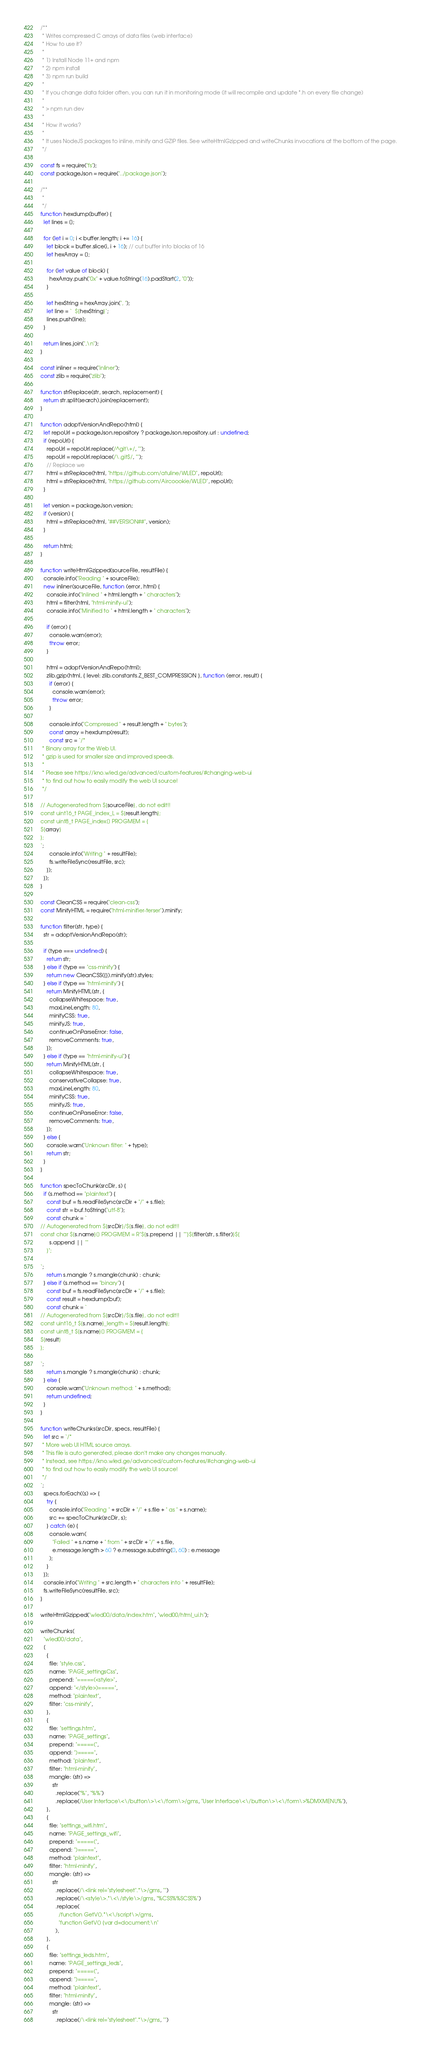<code> <loc_0><loc_0><loc_500><loc_500><_JavaScript_>/**
 * Writes compressed C arrays of data files (web interface)
 * How to use it?
 *
 * 1) Install Node 11+ and npm
 * 2) npm install
 * 3) npm run build
 *
 * If you change data folder often, you can run it in monitoring mode (it will recompile and update *.h on every file change)
 *
 * > npm run dev
 *
 * How it works?
 *
 * It uses NodeJS packages to inline, minify and GZIP files. See writeHtmlGzipped and writeChunks invocations at the bottom of the page.
 */

const fs = require("fs");
const packageJson = require("../package.json");

/**
 *
 */
function hexdump(buffer) {
  let lines = [];

  for (let i = 0; i < buffer.length; i += 16) {
    let block = buffer.slice(i, i + 16); // cut buffer into blocks of 16
    let hexArray = [];

    for (let value of block) {
      hexArray.push("0x" + value.toString(16).padStart(2, "0"));
    }

    let hexString = hexArray.join(", ");
    let line = `  ${hexString}`;
    lines.push(line);
  }

  return lines.join(",\n");
}

const inliner = require("inliner");
const zlib = require("zlib");

function strReplace(str, search, replacement) {
  return str.split(search).join(replacement);
}

function adoptVersionAndRepo(html) {
  let repoUrl = packageJson.repository ? packageJson.repository.url : undefined;
  if (repoUrl) {
    repoUrl = repoUrl.replace(/^git\+/, "");
    repoUrl = repoUrl.replace(/\.git$/, "");
    // Replace we
    html = strReplace(html, "https://github.com/atuline/WLED", repoUrl);
    html = strReplace(html, "https://github.com/Aircoookie/WLED", repoUrl);
  }

  let version = packageJson.version;
  if (version) {
    html = strReplace(html, "##VERSION##", version);
  }

  return html;
}

function writeHtmlGzipped(sourceFile, resultFile) {
  console.info("Reading " + sourceFile);
  new inliner(sourceFile, function (error, html) {
    console.info("Inlined " + html.length + " characters");
    html = filter(html, "html-minify-ui");
    console.info("Minified to " + html.length + " characters");

    if (error) {
      console.warn(error);
      throw error;
    }

    html = adoptVersionAndRepo(html);
    zlib.gzip(html, { level: zlib.constants.Z_BEST_COMPRESSION }, function (error, result) {
      if (error) {
        console.warn(error);
        throw error;
      }

      console.info("Compressed " + result.length + " bytes");
      const array = hexdump(result);
      const src = `/*
 * Binary array for the Web UI.
 * gzip is used for smaller size and improved speeds.
 * 
 * Please see https://kno.wled.ge/advanced/custom-features/#changing-web-ui
 * to find out how to easily modify the web UI source!
 */
 
// Autogenerated from ${sourceFile}, do not edit!!
const uint16_t PAGE_index_L = ${result.length};
const uint8_t PAGE_index[] PROGMEM = {
${array}
};
`;
      console.info("Writing " + resultFile);
      fs.writeFileSync(resultFile, src);
    });
  });
}

const CleanCSS = require("clean-css");
const MinifyHTML = require("html-minifier-terser").minify;

function filter(str, type) {
  str = adoptVersionAndRepo(str);

  if (type === undefined) {
    return str;
  } else if (type == "css-minify") {
    return new CleanCSS({}).minify(str).styles;
  } else if (type == "html-minify") {
    return MinifyHTML(str, {
      collapseWhitespace: true,
      maxLineLength: 80,
      minifyCSS: true,
      minifyJS: true, 
      continueOnParseError: false,
      removeComments: true,
    });
  } else if (type == "html-minify-ui") {
    return MinifyHTML(str, {
      collapseWhitespace: true,
      conservativeCollapse: true,
      maxLineLength: 80,
      minifyCSS: true,
      minifyJS: true, 
      continueOnParseError: false,
      removeComments: true,
    });
  } else {
    console.warn("Unknown filter: " + type);
    return str;
  }
}

function specToChunk(srcDir, s) {
  if (s.method == "plaintext") {
    const buf = fs.readFileSync(srcDir + "/" + s.file);
    const str = buf.toString("utf-8");
    const chunk = `
// Autogenerated from ${srcDir}/${s.file}, do not edit!!
const char ${s.name}[] PROGMEM = R"${s.prepend || ""}${filter(str, s.filter)}${
      s.append || ""
    }";

`;
    return s.mangle ? s.mangle(chunk) : chunk;
  } else if (s.method == "binary") {
    const buf = fs.readFileSync(srcDir + "/" + s.file);
    const result = hexdump(buf);
    const chunk = `
// Autogenerated from ${srcDir}/${s.file}, do not edit!!
const uint16_t ${s.name}_length = ${result.length};
const uint8_t ${s.name}[] PROGMEM = {
${result}
};

`;
    return s.mangle ? s.mangle(chunk) : chunk;
  } else {
    console.warn("Unknown method: " + s.method);
    return undefined;
  }
}

function writeChunks(srcDir, specs, resultFile) {
  let src = `/*
 * More web UI HTML source arrays.
 * This file is auto generated, please don't make any changes manually.
 * Instead, see https://kno.wled.ge/advanced/custom-features/#changing-web-ui
 * to find out how to easily modify the web UI source!
 */ 
`;
  specs.forEach((s) => {
    try {
      console.info("Reading " + srcDir + "/" + s.file + " as " + s.name);
      src += specToChunk(srcDir, s);
    } catch (e) {
      console.warn(
        "Failed " + s.name + " from " + srcDir + "/" + s.file,
        e.message.length > 60 ? e.message.substring(0, 60) : e.message
      );
    }
  });
  console.info("Writing " + src.length + " characters into " + resultFile);
  fs.writeFileSync(resultFile, src);
}

writeHtmlGzipped("wled00/data/index.htm", "wled00/html_ui.h");

writeChunks(
  "wled00/data",
  [
    {
      file: "style.css",
      name: "PAGE_settingsCss",
      prepend: "=====(<style>",
      append: "</style>)=====",
      method: "plaintext",
      filter: "css-minify",
    },
    {
      file: "settings.htm",
      name: "PAGE_settings",
      prepend: "=====(",
      append: ")=====",
      method: "plaintext",
      filter: "html-minify",
      mangle: (str) =>
        str
          .replace("%", "%%")
          .replace(/User Interface\<\/button\>\<\/form\>/gms, "User Interface\<\/button\>\<\/form\>%DMXMENU%"),
    },
    {
      file: "settings_wifi.htm",
      name: "PAGE_settings_wifi",
      prepend: "=====(",
      append: ")=====",
      method: "plaintext",
      filter: "html-minify",
      mangle: (str) =>
        str
          .replace(/\<link rel="stylesheet".*\>/gms, "")
          .replace(/\<style\>.*\<\/style\>/gms, "%CSS%%SCSS%")
          .replace(
            /function GetV().*\<\/script\>/gms,
            "function GetV() {var d=document;\n"
          ),
    },
    {
      file: "settings_leds.htm",
      name: "PAGE_settings_leds",
      prepend: "=====(",
      append: ")=====",
      method: "plaintext",
      filter: "html-minify",
      mangle: (str) =>
        str
          .replace(/\<link rel="stylesheet".*\>/gms, "")</code> 